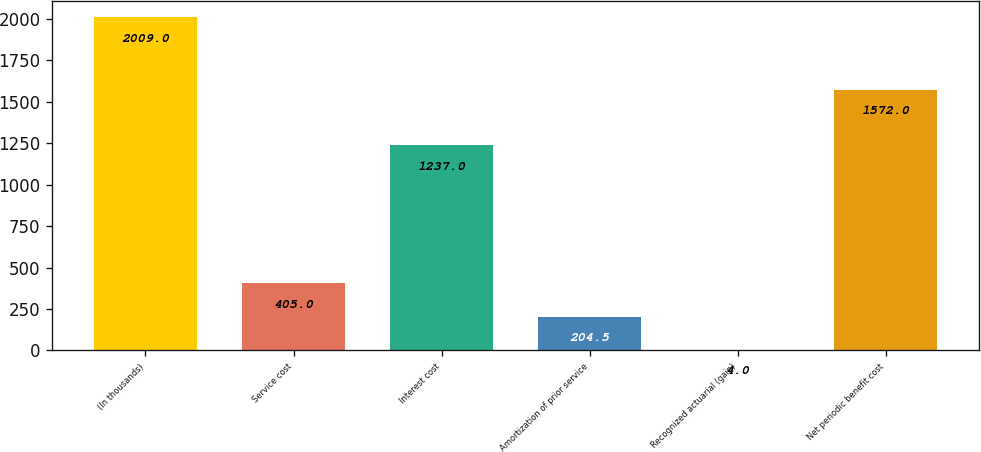<chart> <loc_0><loc_0><loc_500><loc_500><bar_chart><fcel>(In thousands)<fcel>Service cost<fcel>Interest cost<fcel>Amortization of prior service<fcel>Recognized actuarial (gain)<fcel>Net periodic benefit cost<nl><fcel>2009<fcel>405<fcel>1237<fcel>204.5<fcel>4<fcel>1572<nl></chart> 